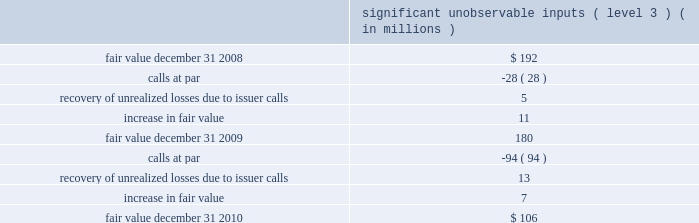Mastercard incorporated notes to consolidated financial statements 2014continued the municipal bond portfolio is comprised of tax exempt bonds and is diversified across states and sectors .
The portfolio has an average credit quality of double-a .
The short-term bond funds invest in fixed income securities , including corporate bonds , mortgage-backed securities and asset-backed securities .
The company holds investments in ars .
Interest on these securities is exempt from u.s .
Federal income tax and the interest rate on the securities typically resets every 35 days .
The securities are fully collateralized by student loans with guarantees , ranging from approximately 95% ( 95 % ) to 98% ( 98 % ) of principal and interest , by the u.s .
Government via the department of education .
Beginning on february 11 , 2008 , the auction mechanism that normally provided liquidity to the ars investments began to fail .
Since mid-february 2008 , all investment positions in the company 2019s ars investment portfolio have experienced failed auctions .
The securities for which auctions have failed have continued to pay interest in accordance with the contractual terms of such instruments and will continue to accrue interest and be auctioned at each respective reset date until the auction succeeds , the issuer redeems the securities or they mature .
During 2008 , ars were reclassified as level 3 from level 2 .
As of december 31 , 2010 , the ars market remained illiquid , but issuer call and redemption activity in the ars student loan sector has occurred periodically since the auctions began to fail .
During 2010 and 2009 , the company did not sell any ars in the auction market , but there were calls at par .
The table below includes a roll-forward of the company 2019s ars investments from january 1 , 2009 to december 31 , 2010 .
Significant unobservable inputs ( level 3 ) ( in millions ) .
The company evaluated the estimated impairment of its ars portfolio to determine if it was other-than- temporary .
The company considered several factors including , but not limited to , the following : ( 1 ) the reasons for the decline in value ( changes in interest rates , credit event , or market fluctuations ) ; ( 2 ) assessments as to whether it is more likely than not that it will hold and not be required to sell the investments for a sufficient period of time to allow for recovery of the cost basis ; ( 3 ) whether the decline is substantial ; and ( 4 ) the historical and anticipated duration of the events causing the decline in value .
The evaluation for other-than-temporary impairments is a quantitative and qualitative process , which is subject to various risks and uncertainties .
The risks and uncertainties include changes in credit quality , market liquidity , timing and amounts of issuer calls and interest rates .
As of december 31 , 2010 , the company believed that the unrealized losses on the ars were not related to credit quality but rather due to the lack of liquidity in the market .
The company believes that it is more .
What is the decrease observed in the fair value of ars investments between 2009 and 2008? 
Rationale: it is the difference between each year's fair value of ars investments .
Computations: (192 - 180)
Answer: 12.0. 